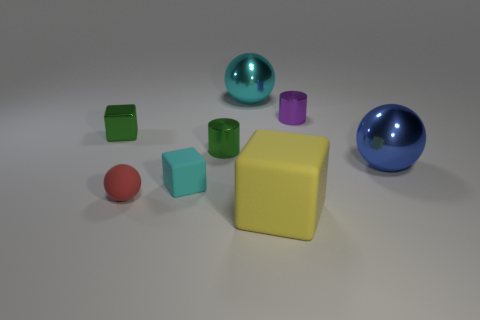Subtract all big spheres. How many spheres are left? 1 Add 1 large green blocks. How many objects exist? 9 Subtract all green cylinders. How many cylinders are left? 1 Subtract all balls. How many objects are left? 5 Add 2 tiny green metal blocks. How many tiny green metal blocks exist? 3 Subtract 0 red cylinders. How many objects are left? 8 Subtract 2 cubes. How many cubes are left? 1 Subtract all brown spheres. Subtract all gray cylinders. How many spheres are left? 3 Subtract all brown cubes. How many red spheres are left? 1 Subtract all purple metal cylinders. Subtract all rubber objects. How many objects are left? 4 